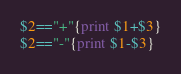Convert code to text. <code><loc_0><loc_0><loc_500><loc_500><_Awk_>$2=="+"{print $1+$3}
$2=="-"{print $1-$3}</code> 